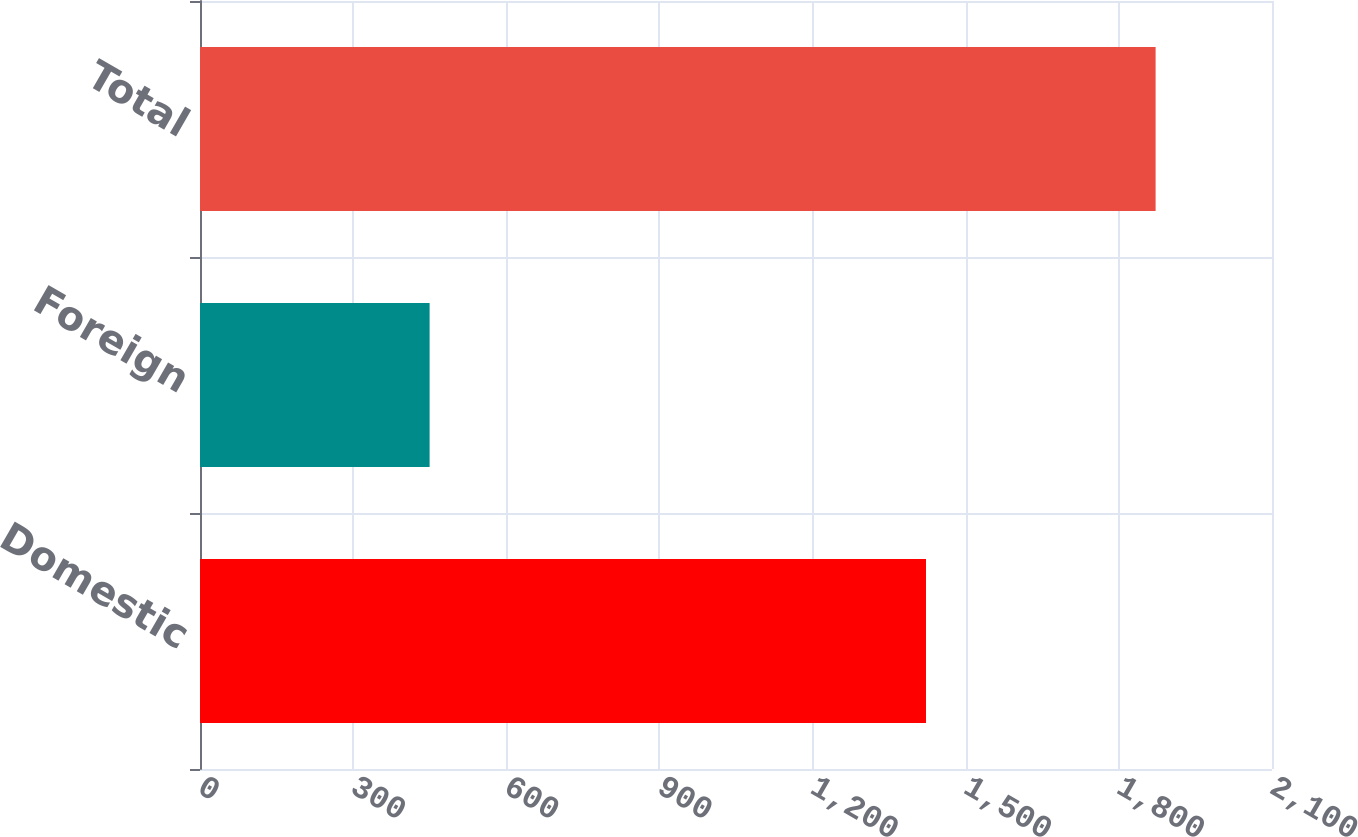<chart> <loc_0><loc_0><loc_500><loc_500><bar_chart><fcel>Domestic<fcel>Foreign<fcel>Total<nl><fcel>1422.2<fcel>449.8<fcel>1872<nl></chart> 